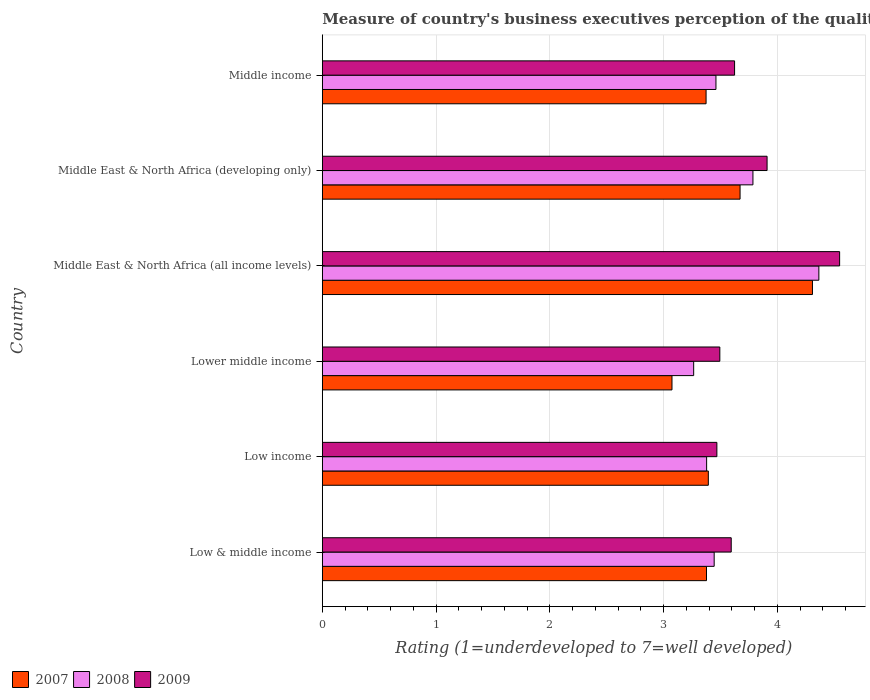How many different coloured bars are there?
Provide a short and direct response. 3. How many groups of bars are there?
Your response must be concise. 6. How many bars are there on the 5th tick from the top?
Your answer should be very brief. 3. What is the label of the 2nd group of bars from the top?
Ensure brevity in your answer.  Middle East & North Africa (developing only). In how many cases, is the number of bars for a given country not equal to the number of legend labels?
Provide a succinct answer. 0. What is the ratings of the quality of port infrastructure in 2007 in Low & middle income?
Offer a very short reply. 3.38. Across all countries, what is the maximum ratings of the quality of port infrastructure in 2007?
Make the answer very short. 4.31. Across all countries, what is the minimum ratings of the quality of port infrastructure in 2007?
Offer a very short reply. 3.07. In which country was the ratings of the quality of port infrastructure in 2008 maximum?
Your answer should be very brief. Middle East & North Africa (all income levels). In which country was the ratings of the quality of port infrastructure in 2007 minimum?
Provide a short and direct response. Lower middle income. What is the total ratings of the quality of port infrastructure in 2008 in the graph?
Offer a very short reply. 21.7. What is the difference between the ratings of the quality of port infrastructure in 2009 in Low & middle income and that in Middle East & North Africa (all income levels)?
Your answer should be compact. -0.95. What is the difference between the ratings of the quality of port infrastructure in 2009 in Middle East & North Africa (developing only) and the ratings of the quality of port infrastructure in 2008 in Low & middle income?
Offer a terse response. 0.47. What is the average ratings of the quality of port infrastructure in 2008 per country?
Your answer should be compact. 3.62. What is the difference between the ratings of the quality of port infrastructure in 2008 and ratings of the quality of port infrastructure in 2009 in Middle East & North Africa (developing only)?
Your response must be concise. -0.12. In how many countries, is the ratings of the quality of port infrastructure in 2008 greater than 3.2 ?
Provide a succinct answer. 6. What is the ratio of the ratings of the quality of port infrastructure in 2009 in Low & middle income to that in Middle East & North Africa (all income levels)?
Make the answer very short. 0.79. Is the ratings of the quality of port infrastructure in 2007 in Lower middle income less than that in Middle income?
Provide a short and direct response. Yes. Is the difference between the ratings of the quality of port infrastructure in 2008 in Lower middle income and Middle income greater than the difference between the ratings of the quality of port infrastructure in 2009 in Lower middle income and Middle income?
Make the answer very short. No. What is the difference between the highest and the second highest ratings of the quality of port infrastructure in 2007?
Give a very brief answer. 0.64. What is the difference between the highest and the lowest ratings of the quality of port infrastructure in 2008?
Your answer should be compact. 1.1. Is the sum of the ratings of the quality of port infrastructure in 2008 in Low income and Middle East & North Africa (all income levels) greater than the maximum ratings of the quality of port infrastructure in 2009 across all countries?
Your answer should be very brief. Yes. What does the 3rd bar from the bottom in Middle income represents?
Offer a very short reply. 2009. Is it the case that in every country, the sum of the ratings of the quality of port infrastructure in 2009 and ratings of the quality of port infrastructure in 2007 is greater than the ratings of the quality of port infrastructure in 2008?
Provide a short and direct response. Yes. How many bars are there?
Your answer should be very brief. 18. Are all the bars in the graph horizontal?
Make the answer very short. Yes. How many countries are there in the graph?
Offer a very short reply. 6. What is the difference between two consecutive major ticks on the X-axis?
Your response must be concise. 1. Does the graph contain grids?
Provide a short and direct response. Yes. How many legend labels are there?
Provide a succinct answer. 3. How are the legend labels stacked?
Offer a very short reply. Horizontal. What is the title of the graph?
Your answer should be very brief. Measure of country's business executives perception of the quality of port infrastructure. What is the label or title of the X-axis?
Provide a short and direct response. Rating (1=underdeveloped to 7=well developed). What is the label or title of the Y-axis?
Offer a terse response. Country. What is the Rating (1=underdeveloped to 7=well developed) of 2007 in Low & middle income?
Provide a short and direct response. 3.38. What is the Rating (1=underdeveloped to 7=well developed) in 2008 in Low & middle income?
Offer a very short reply. 3.44. What is the Rating (1=underdeveloped to 7=well developed) in 2009 in Low & middle income?
Your response must be concise. 3.59. What is the Rating (1=underdeveloped to 7=well developed) of 2007 in Low income?
Offer a terse response. 3.39. What is the Rating (1=underdeveloped to 7=well developed) of 2008 in Low income?
Provide a short and direct response. 3.38. What is the Rating (1=underdeveloped to 7=well developed) in 2009 in Low income?
Provide a succinct answer. 3.47. What is the Rating (1=underdeveloped to 7=well developed) in 2007 in Lower middle income?
Provide a short and direct response. 3.07. What is the Rating (1=underdeveloped to 7=well developed) of 2008 in Lower middle income?
Keep it short and to the point. 3.26. What is the Rating (1=underdeveloped to 7=well developed) of 2009 in Lower middle income?
Offer a very short reply. 3.49. What is the Rating (1=underdeveloped to 7=well developed) of 2007 in Middle East & North Africa (all income levels)?
Your response must be concise. 4.31. What is the Rating (1=underdeveloped to 7=well developed) of 2008 in Middle East & North Africa (all income levels)?
Make the answer very short. 4.36. What is the Rating (1=underdeveloped to 7=well developed) of 2009 in Middle East & North Africa (all income levels)?
Make the answer very short. 4.55. What is the Rating (1=underdeveloped to 7=well developed) in 2007 in Middle East & North Africa (developing only)?
Ensure brevity in your answer.  3.67. What is the Rating (1=underdeveloped to 7=well developed) in 2008 in Middle East & North Africa (developing only)?
Ensure brevity in your answer.  3.78. What is the Rating (1=underdeveloped to 7=well developed) of 2009 in Middle East & North Africa (developing only)?
Your answer should be very brief. 3.91. What is the Rating (1=underdeveloped to 7=well developed) in 2007 in Middle income?
Make the answer very short. 3.37. What is the Rating (1=underdeveloped to 7=well developed) in 2008 in Middle income?
Offer a terse response. 3.46. What is the Rating (1=underdeveloped to 7=well developed) of 2009 in Middle income?
Make the answer very short. 3.62. Across all countries, what is the maximum Rating (1=underdeveloped to 7=well developed) of 2007?
Ensure brevity in your answer.  4.31. Across all countries, what is the maximum Rating (1=underdeveloped to 7=well developed) in 2008?
Keep it short and to the point. 4.36. Across all countries, what is the maximum Rating (1=underdeveloped to 7=well developed) of 2009?
Offer a very short reply. 4.55. Across all countries, what is the minimum Rating (1=underdeveloped to 7=well developed) of 2007?
Provide a short and direct response. 3.07. Across all countries, what is the minimum Rating (1=underdeveloped to 7=well developed) of 2008?
Provide a succinct answer. 3.26. Across all countries, what is the minimum Rating (1=underdeveloped to 7=well developed) in 2009?
Offer a terse response. 3.47. What is the total Rating (1=underdeveloped to 7=well developed) of 2007 in the graph?
Provide a short and direct response. 21.2. What is the total Rating (1=underdeveloped to 7=well developed) of 2008 in the graph?
Your response must be concise. 21.7. What is the total Rating (1=underdeveloped to 7=well developed) of 2009 in the graph?
Make the answer very short. 22.64. What is the difference between the Rating (1=underdeveloped to 7=well developed) of 2007 in Low & middle income and that in Low income?
Offer a very short reply. -0.02. What is the difference between the Rating (1=underdeveloped to 7=well developed) in 2008 in Low & middle income and that in Low income?
Your response must be concise. 0.07. What is the difference between the Rating (1=underdeveloped to 7=well developed) in 2009 in Low & middle income and that in Low income?
Your answer should be compact. 0.13. What is the difference between the Rating (1=underdeveloped to 7=well developed) of 2007 in Low & middle income and that in Lower middle income?
Your response must be concise. 0.3. What is the difference between the Rating (1=underdeveloped to 7=well developed) of 2008 in Low & middle income and that in Lower middle income?
Offer a very short reply. 0.18. What is the difference between the Rating (1=underdeveloped to 7=well developed) in 2009 in Low & middle income and that in Lower middle income?
Keep it short and to the point. 0.1. What is the difference between the Rating (1=underdeveloped to 7=well developed) in 2007 in Low & middle income and that in Middle East & North Africa (all income levels)?
Make the answer very short. -0.93. What is the difference between the Rating (1=underdeveloped to 7=well developed) of 2008 in Low & middle income and that in Middle East & North Africa (all income levels)?
Ensure brevity in your answer.  -0.92. What is the difference between the Rating (1=underdeveloped to 7=well developed) in 2009 in Low & middle income and that in Middle East & North Africa (all income levels)?
Make the answer very short. -0.95. What is the difference between the Rating (1=underdeveloped to 7=well developed) of 2007 in Low & middle income and that in Middle East & North Africa (developing only)?
Give a very brief answer. -0.3. What is the difference between the Rating (1=underdeveloped to 7=well developed) in 2008 in Low & middle income and that in Middle East & North Africa (developing only)?
Your response must be concise. -0.34. What is the difference between the Rating (1=underdeveloped to 7=well developed) in 2009 in Low & middle income and that in Middle East & North Africa (developing only)?
Offer a very short reply. -0.32. What is the difference between the Rating (1=underdeveloped to 7=well developed) in 2007 in Low & middle income and that in Middle income?
Ensure brevity in your answer.  0. What is the difference between the Rating (1=underdeveloped to 7=well developed) of 2008 in Low & middle income and that in Middle income?
Make the answer very short. -0.02. What is the difference between the Rating (1=underdeveloped to 7=well developed) in 2009 in Low & middle income and that in Middle income?
Your answer should be compact. -0.03. What is the difference between the Rating (1=underdeveloped to 7=well developed) of 2007 in Low income and that in Lower middle income?
Your response must be concise. 0.32. What is the difference between the Rating (1=underdeveloped to 7=well developed) of 2008 in Low income and that in Lower middle income?
Your answer should be compact. 0.11. What is the difference between the Rating (1=underdeveloped to 7=well developed) of 2009 in Low income and that in Lower middle income?
Offer a terse response. -0.03. What is the difference between the Rating (1=underdeveloped to 7=well developed) in 2007 in Low income and that in Middle East & North Africa (all income levels)?
Your answer should be compact. -0.92. What is the difference between the Rating (1=underdeveloped to 7=well developed) in 2008 in Low income and that in Middle East & North Africa (all income levels)?
Offer a terse response. -0.99. What is the difference between the Rating (1=underdeveloped to 7=well developed) of 2009 in Low income and that in Middle East & North Africa (all income levels)?
Your answer should be compact. -1.08. What is the difference between the Rating (1=underdeveloped to 7=well developed) of 2007 in Low income and that in Middle East & North Africa (developing only)?
Make the answer very short. -0.28. What is the difference between the Rating (1=underdeveloped to 7=well developed) of 2008 in Low income and that in Middle East & North Africa (developing only)?
Provide a succinct answer. -0.41. What is the difference between the Rating (1=underdeveloped to 7=well developed) of 2009 in Low income and that in Middle East & North Africa (developing only)?
Offer a very short reply. -0.44. What is the difference between the Rating (1=underdeveloped to 7=well developed) of 2007 in Low income and that in Middle income?
Provide a succinct answer. 0.02. What is the difference between the Rating (1=underdeveloped to 7=well developed) of 2008 in Low income and that in Middle income?
Your answer should be compact. -0.08. What is the difference between the Rating (1=underdeveloped to 7=well developed) in 2009 in Low income and that in Middle income?
Provide a succinct answer. -0.16. What is the difference between the Rating (1=underdeveloped to 7=well developed) of 2007 in Lower middle income and that in Middle East & North Africa (all income levels)?
Offer a terse response. -1.23. What is the difference between the Rating (1=underdeveloped to 7=well developed) in 2008 in Lower middle income and that in Middle East & North Africa (all income levels)?
Offer a terse response. -1.1. What is the difference between the Rating (1=underdeveloped to 7=well developed) in 2009 in Lower middle income and that in Middle East & North Africa (all income levels)?
Your answer should be very brief. -1.05. What is the difference between the Rating (1=underdeveloped to 7=well developed) in 2007 in Lower middle income and that in Middle East & North Africa (developing only)?
Make the answer very short. -0.6. What is the difference between the Rating (1=underdeveloped to 7=well developed) of 2008 in Lower middle income and that in Middle East & North Africa (developing only)?
Your response must be concise. -0.52. What is the difference between the Rating (1=underdeveloped to 7=well developed) of 2009 in Lower middle income and that in Middle East & North Africa (developing only)?
Give a very brief answer. -0.42. What is the difference between the Rating (1=underdeveloped to 7=well developed) in 2007 in Lower middle income and that in Middle income?
Your answer should be very brief. -0.3. What is the difference between the Rating (1=underdeveloped to 7=well developed) in 2008 in Lower middle income and that in Middle income?
Make the answer very short. -0.2. What is the difference between the Rating (1=underdeveloped to 7=well developed) in 2009 in Lower middle income and that in Middle income?
Offer a very short reply. -0.13. What is the difference between the Rating (1=underdeveloped to 7=well developed) in 2007 in Middle East & North Africa (all income levels) and that in Middle East & North Africa (developing only)?
Your answer should be very brief. 0.64. What is the difference between the Rating (1=underdeveloped to 7=well developed) of 2008 in Middle East & North Africa (all income levels) and that in Middle East & North Africa (developing only)?
Provide a short and direct response. 0.58. What is the difference between the Rating (1=underdeveloped to 7=well developed) of 2009 in Middle East & North Africa (all income levels) and that in Middle East & North Africa (developing only)?
Provide a succinct answer. 0.64. What is the difference between the Rating (1=underdeveloped to 7=well developed) in 2007 in Middle East & North Africa (all income levels) and that in Middle income?
Keep it short and to the point. 0.94. What is the difference between the Rating (1=underdeveloped to 7=well developed) of 2008 in Middle East & North Africa (all income levels) and that in Middle income?
Provide a succinct answer. 0.9. What is the difference between the Rating (1=underdeveloped to 7=well developed) in 2009 in Middle East & North Africa (all income levels) and that in Middle income?
Provide a short and direct response. 0.92. What is the difference between the Rating (1=underdeveloped to 7=well developed) of 2007 in Middle East & North Africa (developing only) and that in Middle income?
Keep it short and to the point. 0.3. What is the difference between the Rating (1=underdeveloped to 7=well developed) of 2008 in Middle East & North Africa (developing only) and that in Middle income?
Ensure brevity in your answer.  0.33. What is the difference between the Rating (1=underdeveloped to 7=well developed) of 2009 in Middle East & North Africa (developing only) and that in Middle income?
Provide a succinct answer. 0.29. What is the difference between the Rating (1=underdeveloped to 7=well developed) in 2007 in Low & middle income and the Rating (1=underdeveloped to 7=well developed) in 2008 in Low income?
Give a very brief answer. -0. What is the difference between the Rating (1=underdeveloped to 7=well developed) in 2007 in Low & middle income and the Rating (1=underdeveloped to 7=well developed) in 2009 in Low income?
Provide a short and direct response. -0.09. What is the difference between the Rating (1=underdeveloped to 7=well developed) of 2008 in Low & middle income and the Rating (1=underdeveloped to 7=well developed) of 2009 in Low income?
Offer a very short reply. -0.02. What is the difference between the Rating (1=underdeveloped to 7=well developed) of 2007 in Low & middle income and the Rating (1=underdeveloped to 7=well developed) of 2008 in Lower middle income?
Offer a terse response. 0.11. What is the difference between the Rating (1=underdeveloped to 7=well developed) of 2007 in Low & middle income and the Rating (1=underdeveloped to 7=well developed) of 2009 in Lower middle income?
Your answer should be compact. -0.12. What is the difference between the Rating (1=underdeveloped to 7=well developed) of 2008 in Low & middle income and the Rating (1=underdeveloped to 7=well developed) of 2009 in Lower middle income?
Your answer should be compact. -0.05. What is the difference between the Rating (1=underdeveloped to 7=well developed) in 2007 in Low & middle income and the Rating (1=underdeveloped to 7=well developed) in 2008 in Middle East & North Africa (all income levels)?
Offer a very short reply. -0.99. What is the difference between the Rating (1=underdeveloped to 7=well developed) of 2007 in Low & middle income and the Rating (1=underdeveloped to 7=well developed) of 2009 in Middle East & North Africa (all income levels)?
Your response must be concise. -1.17. What is the difference between the Rating (1=underdeveloped to 7=well developed) of 2008 in Low & middle income and the Rating (1=underdeveloped to 7=well developed) of 2009 in Middle East & North Africa (all income levels)?
Offer a terse response. -1.1. What is the difference between the Rating (1=underdeveloped to 7=well developed) of 2007 in Low & middle income and the Rating (1=underdeveloped to 7=well developed) of 2008 in Middle East & North Africa (developing only)?
Provide a succinct answer. -0.41. What is the difference between the Rating (1=underdeveloped to 7=well developed) in 2007 in Low & middle income and the Rating (1=underdeveloped to 7=well developed) in 2009 in Middle East & North Africa (developing only)?
Offer a terse response. -0.53. What is the difference between the Rating (1=underdeveloped to 7=well developed) in 2008 in Low & middle income and the Rating (1=underdeveloped to 7=well developed) in 2009 in Middle East & North Africa (developing only)?
Keep it short and to the point. -0.47. What is the difference between the Rating (1=underdeveloped to 7=well developed) in 2007 in Low & middle income and the Rating (1=underdeveloped to 7=well developed) in 2008 in Middle income?
Offer a terse response. -0.08. What is the difference between the Rating (1=underdeveloped to 7=well developed) of 2007 in Low & middle income and the Rating (1=underdeveloped to 7=well developed) of 2009 in Middle income?
Make the answer very short. -0.25. What is the difference between the Rating (1=underdeveloped to 7=well developed) in 2008 in Low & middle income and the Rating (1=underdeveloped to 7=well developed) in 2009 in Middle income?
Provide a succinct answer. -0.18. What is the difference between the Rating (1=underdeveloped to 7=well developed) in 2007 in Low income and the Rating (1=underdeveloped to 7=well developed) in 2008 in Lower middle income?
Give a very brief answer. 0.13. What is the difference between the Rating (1=underdeveloped to 7=well developed) of 2007 in Low income and the Rating (1=underdeveloped to 7=well developed) of 2009 in Lower middle income?
Provide a short and direct response. -0.1. What is the difference between the Rating (1=underdeveloped to 7=well developed) in 2008 in Low income and the Rating (1=underdeveloped to 7=well developed) in 2009 in Lower middle income?
Your answer should be very brief. -0.12. What is the difference between the Rating (1=underdeveloped to 7=well developed) in 2007 in Low income and the Rating (1=underdeveloped to 7=well developed) in 2008 in Middle East & North Africa (all income levels)?
Give a very brief answer. -0.97. What is the difference between the Rating (1=underdeveloped to 7=well developed) in 2007 in Low income and the Rating (1=underdeveloped to 7=well developed) in 2009 in Middle East & North Africa (all income levels)?
Provide a succinct answer. -1.15. What is the difference between the Rating (1=underdeveloped to 7=well developed) in 2008 in Low income and the Rating (1=underdeveloped to 7=well developed) in 2009 in Middle East & North Africa (all income levels)?
Keep it short and to the point. -1.17. What is the difference between the Rating (1=underdeveloped to 7=well developed) of 2007 in Low income and the Rating (1=underdeveloped to 7=well developed) of 2008 in Middle East & North Africa (developing only)?
Ensure brevity in your answer.  -0.39. What is the difference between the Rating (1=underdeveloped to 7=well developed) in 2007 in Low income and the Rating (1=underdeveloped to 7=well developed) in 2009 in Middle East & North Africa (developing only)?
Make the answer very short. -0.52. What is the difference between the Rating (1=underdeveloped to 7=well developed) in 2008 in Low income and the Rating (1=underdeveloped to 7=well developed) in 2009 in Middle East & North Africa (developing only)?
Give a very brief answer. -0.53. What is the difference between the Rating (1=underdeveloped to 7=well developed) in 2007 in Low income and the Rating (1=underdeveloped to 7=well developed) in 2008 in Middle income?
Ensure brevity in your answer.  -0.07. What is the difference between the Rating (1=underdeveloped to 7=well developed) of 2007 in Low income and the Rating (1=underdeveloped to 7=well developed) of 2009 in Middle income?
Keep it short and to the point. -0.23. What is the difference between the Rating (1=underdeveloped to 7=well developed) of 2008 in Low income and the Rating (1=underdeveloped to 7=well developed) of 2009 in Middle income?
Give a very brief answer. -0.25. What is the difference between the Rating (1=underdeveloped to 7=well developed) of 2007 in Lower middle income and the Rating (1=underdeveloped to 7=well developed) of 2008 in Middle East & North Africa (all income levels)?
Make the answer very short. -1.29. What is the difference between the Rating (1=underdeveloped to 7=well developed) of 2007 in Lower middle income and the Rating (1=underdeveloped to 7=well developed) of 2009 in Middle East & North Africa (all income levels)?
Keep it short and to the point. -1.47. What is the difference between the Rating (1=underdeveloped to 7=well developed) in 2008 in Lower middle income and the Rating (1=underdeveloped to 7=well developed) in 2009 in Middle East & North Africa (all income levels)?
Your answer should be very brief. -1.28. What is the difference between the Rating (1=underdeveloped to 7=well developed) of 2007 in Lower middle income and the Rating (1=underdeveloped to 7=well developed) of 2008 in Middle East & North Africa (developing only)?
Offer a very short reply. -0.71. What is the difference between the Rating (1=underdeveloped to 7=well developed) in 2007 in Lower middle income and the Rating (1=underdeveloped to 7=well developed) in 2009 in Middle East & North Africa (developing only)?
Ensure brevity in your answer.  -0.84. What is the difference between the Rating (1=underdeveloped to 7=well developed) in 2008 in Lower middle income and the Rating (1=underdeveloped to 7=well developed) in 2009 in Middle East & North Africa (developing only)?
Offer a very short reply. -0.65. What is the difference between the Rating (1=underdeveloped to 7=well developed) in 2007 in Lower middle income and the Rating (1=underdeveloped to 7=well developed) in 2008 in Middle income?
Make the answer very short. -0.39. What is the difference between the Rating (1=underdeveloped to 7=well developed) of 2007 in Lower middle income and the Rating (1=underdeveloped to 7=well developed) of 2009 in Middle income?
Provide a succinct answer. -0.55. What is the difference between the Rating (1=underdeveloped to 7=well developed) in 2008 in Lower middle income and the Rating (1=underdeveloped to 7=well developed) in 2009 in Middle income?
Your response must be concise. -0.36. What is the difference between the Rating (1=underdeveloped to 7=well developed) in 2007 in Middle East & North Africa (all income levels) and the Rating (1=underdeveloped to 7=well developed) in 2008 in Middle East & North Africa (developing only)?
Your answer should be very brief. 0.52. What is the difference between the Rating (1=underdeveloped to 7=well developed) in 2007 in Middle East & North Africa (all income levels) and the Rating (1=underdeveloped to 7=well developed) in 2009 in Middle East & North Africa (developing only)?
Offer a terse response. 0.4. What is the difference between the Rating (1=underdeveloped to 7=well developed) in 2008 in Middle East & North Africa (all income levels) and the Rating (1=underdeveloped to 7=well developed) in 2009 in Middle East & North Africa (developing only)?
Give a very brief answer. 0.46. What is the difference between the Rating (1=underdeveloped to 7=well developed) of 2007 in Middle East & North Africa (all income levels) and the Rating (1=underdeveloped to 7=well developed) of 2008 in Middle income?
Your response must be concise. 0.85. What is the difference between the Rating (1=underdeveloped to 7=well developed) of 2007 in Middle East & North Africa (all income levels) and the Rating (1=underdeveloped to 7=well developed) of 2009 in Middle income?
Your answer should be very brief. 0.68. What is the difference between the Rating (1=underdeveloped to 7=well developed) in 2008 in Middle East & North Africa (all income levels) and the Rating (1=underdeveloped to 7=well developed) in 2009 in Middle income?
Your answer should be very brief. 0.74. What is the difference between the Rating (1=underdeveloped to 7=well developed) of 2007 in Middle East & North Africa (developing only) and the Rating (1=underdeveloped to 7=well developed) of 2008 in Middle income?
Your answer should be compact. 0.21. What is the difference between the Rating (1=underdeveloped to 7=well developed) of 2007 in Middle East & North Africa (developing only) and the Rating (1=underdeveloped to 7=well developed) of 2009 in Middle income?
Provide a succinct answer. 0.05. What is the difference between the Rating (1=underdeveloped to 7=well developed) in 2008 in Middle East & North Africa (developing only) and the Rating (1=underdeveloped to 7=well developed) in 2009 in Middle income?
Keep it short and to the point. 0.16. What is the average Rating (1=underdeveloped to 7=well developed) of 2007 per country?
Your response must be concise. 3.53. What is the average Rating (1=underdeveloped to 7=well developed) of 2008 per country?
Ensure brevity in your answer.  3.62. What is the average Rating (1=underdeveloped to 7=well developed) in 2009 per country?
Offer a very short reply. 3.77. What is the difference between the Rating (1=underdeveloped to 7=well developed) in 2007 and Rating (1=underdeveloped to 7=well developed) in 2008 in Low & middle income?
Ensure brevity in your answer.  -0.07. What is the difference between the Rating (1=underdeveloped to 7=well developed) of 2007 and Rating (1=underdeveloped to 7=well developed) of 2009 in Low & middle income?
Ensure brevity in your answer.  -0.22. What is the difference between the Rating (1=underdeveloped to 7=well developed) of 2008 and Rating (1=underdeveloped to 7=well developed) of 2009 in Low & middle income?
Provide a short and direct response. -0.15. What is the difference between the Rating (1=underdeveloped to 7=well developed) in 2007 and Rating (1=underdeveloped to 7=well developed) in 2008 in Low income?
Your response must be concise. 0.01. What is the difference between the Rating (1=underdeveloped to 7=well developed) of 2007 and Rating (1=underdeveloped to 7=well developed) of 2009 in Low income?
Keep it short and to the point. -0.08. What is the difference between the Rating (1=underdeveloped to 7=well developed) in 2008 and Rating (1=underdeveloped to 7=well developed) in 2009 in Low income?
Offer a terse response. -0.09. What is the difference between the Rating (1=underdeveloped to 7=well developed) of 2007 and Rating (1=underdeveloped to 7=well developed) of 2008 in Lower middle income?
Offer a terse response. -0.19. What is the difference between the Rating (1=underdeveloped to 7=well developed) of 2007 and Rating (1=underdeveloped to 7=well developed) of 2009 in Lower middle income?
Keep it short and to the point. -0.42. What is the difference between the Rating (1=underdeveloped to 7=well developed) in 2008 and Rating (1=underdeveloped to 7=well developed) in 2009 in Lower middle income?
Offer a very short reply. -0.23. What is the difference between the Rating (1=underdeveloped to 7=well developed) in 2007 and Rating (1=underdeveloped to 7=well developed) in 2008 in Middle East & North Africa (all income levels)?
Provide a succinct answer. -0.06. What is the difference between the Rating (1=underdeveloped to 7=well developed) of 2007 and Rating (1=underdeveloped to 7=well developed) of 2009 in Middle East & North Africa (all income levels)?
Your response must be concise. -0.24. What is the difference between the Rating (1=underdeveloped to 7=well developed) in 2008 and Rating (1=underdeveloped to 7=well developed) in 2009 in Middle East & North Africa (all income levels)?
Give a very brief answer. -0.18. What is the difference between the Rating (1=underdeveloped to 7=well developed) in 2007 and Rating (1=underdeveloped to 7=well developed) in 2008 in Middle East & North Africa (developing only)?
Make the answer very short. -0.11. What is the difference between the Rating (1=underdeveloped to 7=well developed) of 2007 and Rating (1=underdeveloped to 7=well developed) of 2009 in Middle East & North Africa (developing only)?
Ensure brevity in your answer.  -0.24. What is the difference between the Rating (1=underdeveloped to 7=well developed) in 2008 and Rating (1=underdeveloped to 7=well developed) in 2009 in Middle East & North Africa (developing only)?
Offer a very short reply. -0.12. What is the difference between the Rating (1=underdeveloped to 7=well developed) in 2007 and Rating (1=underdeveloped to 7=well developed) in 2008 in Middle income?
Make the answer very short. -0.09. What is the difference between the Rating (1=underdeveloped to 7=well developed) in 2007 and Rating (1=underdeveloped to 7=well developed) in 2009 in Middle income?
Provide a succinct answer. -0.25. What is the difference between the Rating (1=underdeveloped to 7=well developed) of 2008 and Rating (1=underdeveloped to 7=well developed) of 2009 in Middle income?
Keep it short and to the point. -0.16. What is the ratio of the Rating (1=underdeveloped to 7=well developed) in 2008 in Low & middle income to that in Low income?
Provide a succinct answer. 1.02. What is the ratio of the Rating (1=underdeveloped to 7=well developed) in 2009 in Low & middle income to that in Low income?
Offer a terse response. 1.04. What is the ratio of the Rating (1=underdeveloped to 7=well developed) in 2007 in Low & middle income to that in Lower middle income?
Your response must be concise. 1.1. What is the ratio of the Rating (1=underdeveloped to 7=well developed) of 2008 in Low & middle income to that in Lower middle income?
Your answer should be compact. 1.06. What is the ratio of the Rating (1=underdeveloped to 7=well developed) in 2009 in Low & middle income to that in Lower middle income?
Make the answer very short. 1.03. What is the ratio of the Rating (1=underdeveloped to 7=well developed) of 2007 in Low & middle income to that in Middle East & North Africa (all income levels)?
Provide a succinct answer. 0.78. What is the ratio of the Rating (1=underdeveloped to 7=well developed) of 2008 in Low & middle income to that in Middle East & North Africa (all income levels)?
Offer a very short reply. 0.79. What is the ratio of the Rating (1=underdeveloped to 7=well developed) of 2009 in Low & middle income to that in Middle East & North Africa (all income levels)?
Keep it short and to the point. 0.79. What is the ratio of the Rating (1=underdeveloped to 7=well developed) of 2007 in Low & middle income to that in Middle East & North Africa (developing only)?
Your answer should be compact. 0.92. What is the ratio of the Rating (1=underdeveloped to 7=well developed) of 2008 in Low & middle income to that in Middle East & North Africa (developing only)?
Your answer should be very brief. 0.91. What is the ratio of the Rating (1=underdeveloped to 7=well developed) of 2009 in Low & middle income to that in Middle East & North Africa (developing only)?
Your answer should be compact. 0.92. What is the ratio of the Rating (1=underdeveloped to 7=well developed) in 2007 in Low income to that in Lower middle income?
Your answer should be compact. 1.1. What is the ratio of the Rating (1=underdeveloped to 7=well developed) in 2008 in Low income to that in Lower middle income?
Your answer should be compact. 1.03. What is the ratio of the Rating (1=underdeveloped to 7=well developed) in 2009 in Low income to that in Lower middle income?
Offer a very short reply. 0.99. What is the ratio of the Rating (1=underdeveloped to 7=well developed) of 2007 in Low income to that in Middle East & North Africa (all income levels)?
Provide a succinct answer. 0.79. What is the ratio of the Rating (1=underdeveloped to 7=well developed) in 2008 in Low income to that in Middle East & North Africa (all income levels)?
Give a very brief answer. 0.77. What is the ratio of the Rating (1=underdeveloped to 7=well developed) of 2009 in Low income to that in Middle East & North Africa (all income levels)?
Your answer should be compact. 0.76. What is the ratio of the Rating (1=underdeveloped to 7=well developed) of 2007 in Low income to that in Middle East & North Africa (developing only)?
Your response must be concise. 0.92. What is the ratio of the Rating (1=underdeveloped to 7=well developed) of 2008 in Low income to that in Middle East & North Africa (developing only)?
Offer a terse response. 0.89. What is the ratio of the Rating (1=underdeveloped to 7=well developed) in 2009 in Low income to that in Middle East & North Africa (developing only)?
Your answer should be compact. 0.89. What is the ratio of the Rating (1=underdeveloped to 7=well developed) in 2007 in Low income to that in Middle income?
Make the answer very short. 1.01. What is the ratio of the Rating (1=underdeveloped to 7=well developed) in 2008 in Low income to that in Middle income?
Give a very brief answer. 0.98. What is the ratio of the Rating (1=underdeveloped to 7=well developed) of 2009 in Low income to that in Middle income?
Keep it short and to the point. 0.96. What is the ratio of the Rating (1=underdeveloped to 7=well developed) in 2007 in Lower middle income to that in Middle East & North Africa (all income levels)?
Give a very brief answer. 0.71. What is the ratio of the Rating (1=underdeveloped to 7=well developed) in 2008 in Lower middle income to that in Middle East & North Africa (all income levels)?
Ensure brevity in your answer.  0.75. What is the ratio of the Rating (1=underdeveloped to 7=well developed) in 2009 in Lower middle income to that in Middle East & North Africa (all income levels)?
Your answer should be very brief. 0.77. What is the ratio of the Rating (1=underdeveloped to 7=well developed) of 2007 in Lower middle income to that in Middle East & North Africa (developing only)?
Keep it short and to the point. 0.84. What is the ratio of the Rating (1=underdeveloped to 7=well developed) of 2008 in Lower middle income to that in Middle East & North Africa (developing only)?
Provide a short and direct response. 0.86. What is the ratio of the Rating (1=underdeveloped to 7=well developed) in 2009 in Lower middle income to that in Middle East & North Africa (developing only)?
Your answer should be compact. 0.89. What is the ratio of the Rating (1=underdeveloped to 7=well developed) of 2007 in Lower middle income to that in Middle income?
Give a very brief answer. 0.91. What is the ratio of the Rating (1=underdeveloped to 7=well developed) of 2008 in Lower middle income to that in Middle income?
Offer a terse response. 0.94. What is the ratio of the Rating (1=underdeveloped to 7=well developed) in 2009 in Lower middle income to that in Middle income?
Offer a terse response. 0.96. What is the ratio of the Rating (1=underdeveloped to 7=well developed) in 2007 in Middle East & North Africa (all income levels) to that in Middle East & North Africa (developing only)?
Provide a short and direct response. 1.17. What is the ratio of the Rating (1=underdeveloped to 7=well developed) in 2008 in Middle East & North Africa (all income levels) to that in Middle East & North Africa (developing only)?
Offer a very short reply. 1.15. What is the ratio of the Rating (1=underdeveloped to 7=well developed) of 2009 in Middle East & North Africa (all income levels) to that in Middle East & North Africa (developing only)?
Your answer should be compact. 1.16. What is the ratio of the Rating (1=underdeveloped to 7=well developed) in 2007 in Middle East & North Africa (all income levels) to that in Middle income?
Offer a very short reply. 1.28. What is the ratio of the Rating (1=underdeveloped to 7=well developed) of 2008 in Middle East & North Africa (all income levels) to that in Middle income?
Make the answer very short. 1.26. What is the ratio of the Rating (1=underdeveloped to 7=well developed) of 2009 in Middle East & North Africa (all income levels) to that in Middle income?
Keep it short and to the point. 1.25. What is the ratio of the Rating (1=underdeveloped to 7=well developed) of 2007 in Middle East & North Africa (developing only) to that in Middle income?
Offer a very short reply. 1.09. What is the ratio of the Rating (1=underdeveloped to 7=well developed) of 2008 in Middle East & North Africa (developing only) to that in Middle income?
Ensure brevity in your answer.  1.09. What is the ratio of the Rating (1=underdeveloped to 7=well developed) in 2009 in Middle East & North Africa (developing only) to that in Middle income?
Your answer should be compact. 1.08. What is the difference between the highest and the second highest Rating (1=underdeveloped to 7=well developed) in 2007?
Offer a terse response. 0.64. What is the difference between the highest and the second highest Rating (1=underdeveloped to 7=well developed) in 2008?
Provide a short and direct response. 0.58. What is the difference between the highest and the second highest Rating (1=underdeveloped to 7=well developed) of 2009?
Ensure brevity in your answer.  0.64. What is the difference between the highest and the lowest Rating (1=underdeveloped to 7=well developed) in 2007?
Provide a succinct answer. 1.23. What is the difference between the highest and the lowest Rating (1=underdeveloped to 7=well developed) of 2008?
Provide a succinct answer. 1.1. What is the difference between the highest and the lowest Rating (1=underdeveloped to 7=well developed) in 2009?
Provide a succinct answer. 1.08. 